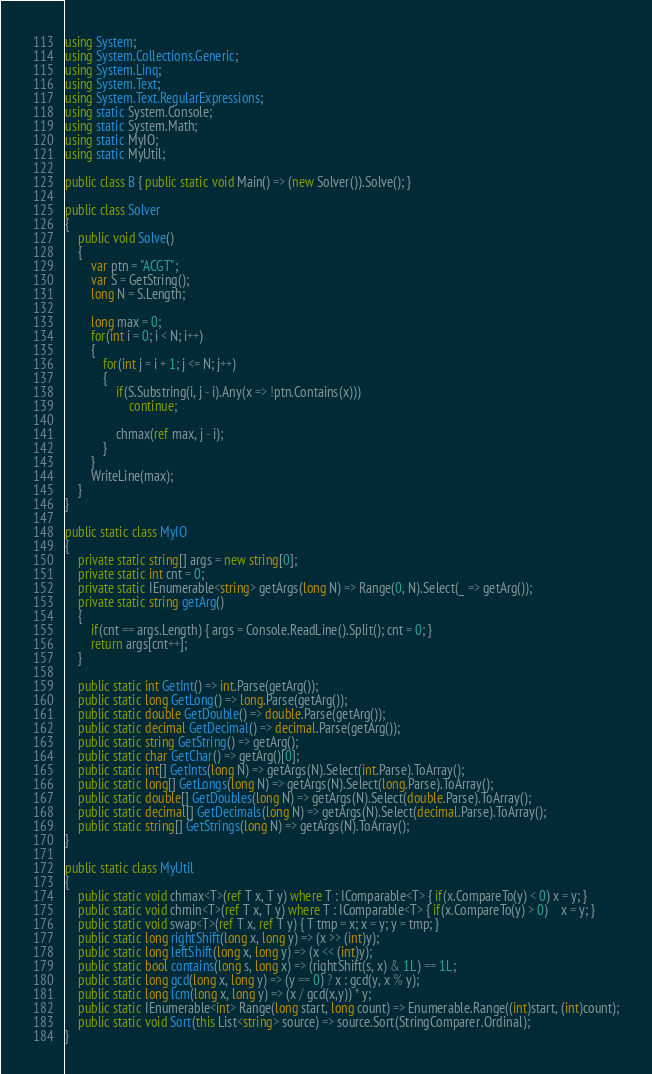Convert code to text. <code><loc_0><loc_0><loc_500><loc_500><_C#_>using System;
using System.Collections.Generic;
using System.Linq;
using System.Text;
using System.Text.RegularExpressions;
using static System.Console;
using static System.Math;
using static MyIO;
using static MyUtil;

public class B { public static void Main() => (new Solver()).Solve(); }

public class Solver
{
	public void Solve()
	{
		var ptn = "ACGT";
		var S = GetString();
		long N = S.Length;

		long max = 0;
		for(int i = 0; i < N; i++)
		{
			for(int j = i + 1; j <= N; j++)
			{
				if(S.Substring(i, j - i).Any(x => !ptn.Contains(x)))
					continue;

				chmax(ref max, j - i);
			}
		}
		WriteLine(max);
	}
}

public static class MyIO
{
	private static string[] args = new string[0];
	private static int cnt = 0;
	private static IEnumerable<string> getArgs(long N) => Range(0, N).Select(_ => getArg());
	private static string getArg()
	{
		if(cnt == args.Length) { args = Console.ReadLine().Split(); cnt = 0; }
		return args[cnt++];
	}

	public static int GetInt() => int.Parse(getArg());
	public static long GetLong() => long.Parse(getArg());
	public static double GetDouble() => double.Parse(getArg());
	public static decimal GetDecimal() => decimal.Parse(getArg());
	public static string GetString() => getArg();
	public static char GetChar() => getArg()[0];
	public static int[] GetInts(long N) => getArgs(N).Select(int.Parse).ToArray();
	public static long[] GetLongs(long N) => getArgs(N).Select(long.Parse).ToArray();
	public static double[] GetDoubles(long N) => getArgs(N).Select(double.Parse).ToArray();
	public static decimal[] GetDecimals(long N) => getArgs(N).Select(decimal.Parse).ToArray();
	public static string[] GetStrings(long N) => getArgs(N).ToArray();
}

public static class MyUtil
{
	public static void chmax<T>(ref T x, T y) where T : IComparable<T> { if(x.CompareTo(y) < 0) x = y; }
	public static void chmin<T>(ref T x, T y) where T : IComparable<T> { if(x.CompareTo(y) > 0)	x = y; }
	public static void swap<T>(ref T x, ref T y) { T tmp = x; x = y; y = tmp; }
	public static long rightShift(long x, long y) => (x >> (int)y);
	public static long leftShift(long x, long y) => (x << (int)y);
	public static bool contains(long s, long x) => (rightShift(s, x) & 1L) == 1L;
	public static long gcd(long x, long y) => (y == 0) ? x : gcd(y, x % y);
	public static long lcm(long x, long y) => (x / gcd(x,y)) * y;	
	public static IEnumerable<int> Range(long start, long count) => Enumerable.Range((int)start, (int)count);
	public static void Sort(this List<string> source) => source.Sort(StringComparer.Ordinal);
}
</code> 